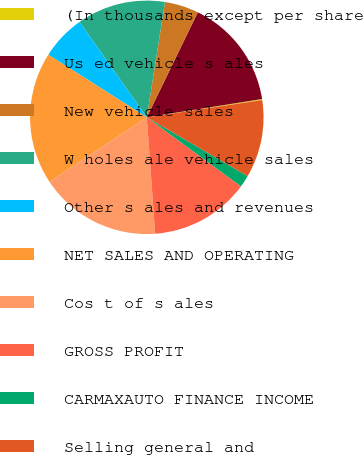<chart> <loc_0><loc_0><loc_500><loc_500><pie_chart><fcel>(In thousands except per share<fcel>Us ed vehicle s ales<fcel>New vehicle sales<fcel>W holes ale vehicle sales<fcel>Other s ales and revenues<fcel>NET SALES AND OPERATING<fcel>Cos t of s ales<fcel>GROSS PROFIT<fcel>CARMAXAUTO FINANCE INCOME<fcel>Selling general and<nl><fcel>0.15%<fcel>15.3%<fcel>4.7%<fcel>12.27%<fcel>6.21%<fcel>18.33%<fcel>16.82%<fcel>13.79%<fcel>1.67%<fcel>10.76%<nl></chart> 